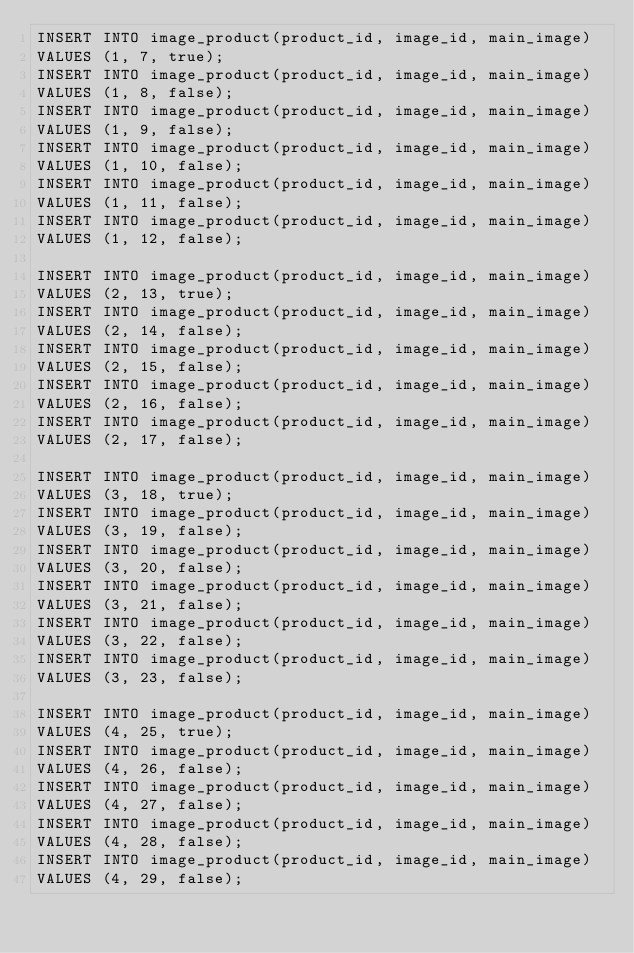Convert code to text. <code><loc_0><loc_0><loc_500><loc_500><_SQL_>INSERT INTO image_product(product_id, image_id, main_image)
VALUES (1, 7, true);
INSERT INTO image_product(product_id, image_id, main_image)
VALUES (1, 8, false);
INSERT INTO image_product(product_id, image_id, main_image)
VALUES (1, 9, false);
INSERT INTO image_product(product_id, image_id, main_image)
VALUES (1, 10, false);
INSERT INTO image_product(product_id, image_id, main_image)
VALUES (1, 11, false);
INSERT INTO image_product(product_id, image_id, main_image)
VALUES (1, 12, false);

INSERT INTO image_product(product_id, image_id, main_image)
VALUES (2, 13, true);
INSERT INTO image_product(product_id, image_id, main_image)
VALUES (2, 14, false);
INSERT INTO image_product(product_id, image_id, main_image)
VALUES (2, 15, false);
INSERT INTO image_product(product_id, image_id, main_image)
VALUES (2, 16, false);
INSERT INTO image_product(product_id, image_id, main_image)
VALUES (2, 17, false);

INSERT INTO image_product(product_id, image_id, main_image)
VALUES (3, 18, true);
INSERT INTO image_product(product_id, image_id, main_image)
VALUES (3, 19, false);
INSERT INTO image_product(product_id, image_id, main_image)
VALUES (3, 20, false);
INSERT INTO image_product(product_id, image_id, main_image)
VALUES (3, 21, false);
INSERT INTO image_product(product_id, image_id, main_image)
VALUES (3, 22, false);
INSERT INTO image_product(product_id, image_id, main_image)
VALUES (3, 23, false);

INSERT INTO image_product(product_id, image_id, main_image)
VALUES (4, 25, true);
INSERT INTO image_product(product_id, image_id, main_image)
VALUES (4, 26, false);
INSERT INTO image_product(product_id, image_id, main_image)
VALUES (4, 27, false);
INSERT INTO image_product(product_id, image_id, main_image)
VALUES (4, 28, false);
INSERT INTO image_product(product_id, image_id, main_image)
VALUES (4, 29, false);
</code> 